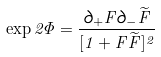<formula> <loc_0><loc_0><loc_500><loc_500>\exp { 2 \Phi } = \frac { \partial _ { + } F \partial _ { - } \widetilde { F } } { [ 1 + F \widetilde { F } ] ^ { 2 } }</formula> 